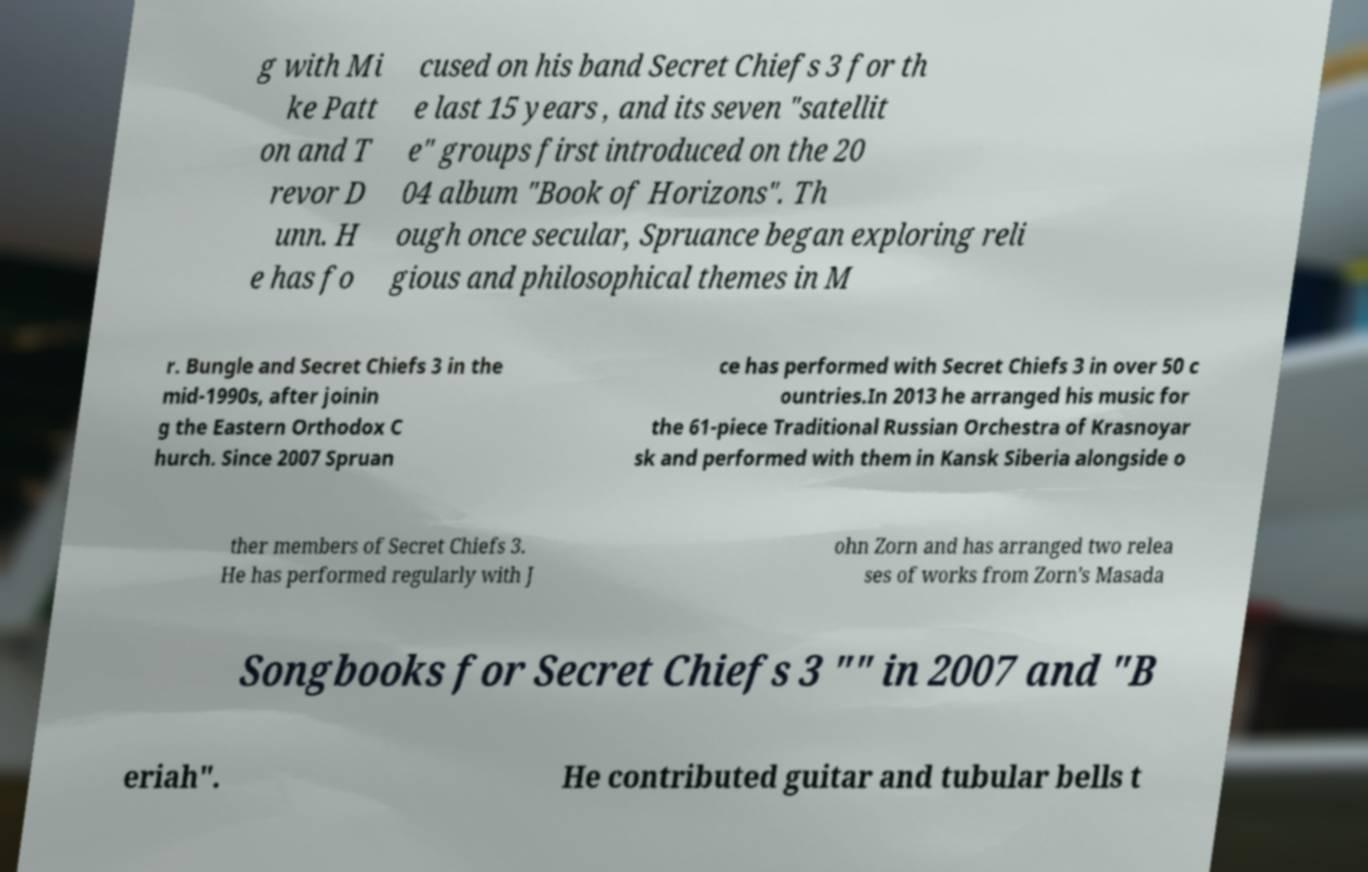For documentation purposes, I need the text within this image transcribed. Could you provide that? g with Mi ke Patt on and T revor D unn. H e has fo cused on his band Secret Chiefs 3 for th e last 15 years , and its seven "satellit e" groups first introduced on the 20 04 album "Book of Horizons". Th ough once secular, Spruance began exploring reli gious and philosophical themes in M r. Bungle and Secret Chiefs 3 in the mid-1990s, after joinin g the Eastern Orthodox C hurch. Since 2007 Spruan ce has performed with Secret Chiefs 3 in over 50 c ountries.In 2013 he arranged his music for the 61-piece Traditional Russian Orchestra of Krasnoyar sk and performed with them in Kansk Siberia alongside o ther members of Secret Chiefs 3. He has performed regularly with J ohn Zorn and has arranged two relea ses of works from Zorn's Masada Songbooks for Secret Chiefs 3 "" in 2007 and "B eriah". He contributed guitar and tubular bells t 